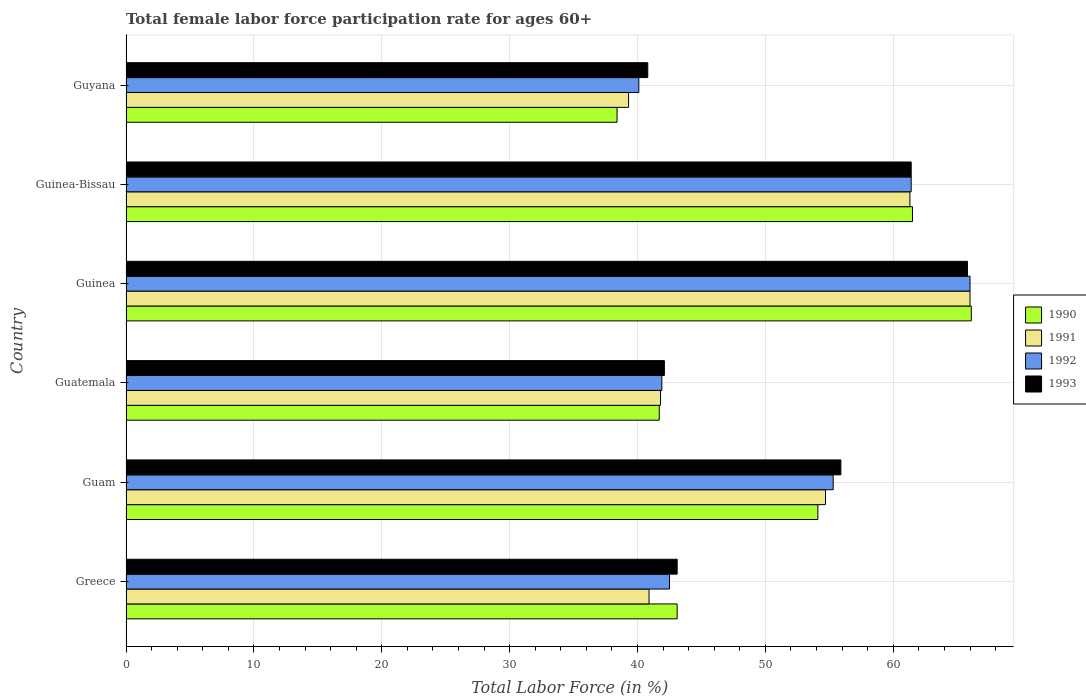How many groups of bars are there?
Your response must be concise. 6. Are the number of bars per tick equal to the number of legend labels?
Give a very brief answer. Yes. Are the number of bars on each tick of the Y-axis equal?
Your answer should be compact. Yes. How many bars are there on the 2nd tick from the top?
Your answer should be very brief. 4. What is the label of the 2nd group of bars from the top?
Your answer should be very brief. Guinea-Bissau. In how many cases, is the number of bars for a given country not equal to the number of legend labels?
Offer a very short reply. 0. What is the female labor force participation rate in 1993 in Guinea?
Keep it short and to the point. 65.8. Across all countries, what is the maximum female labor force participation rate in 1990?
Keep it short and to the point. 66.1. Across all countries, what is the minimum female labor force participation rate in 1991?
Your response must be concise. 39.3. In which country was the female labor force participation rate in 1992 maximum?
Offer a terse response. Guinea. In which country was the female labor force participation rate in 1993 minimum?
Your answer should be compact. Guyana. What is the total female labor force participation rate in 1993 in the graph?
Ensure brevity in your answer.  309.1. What is the difference between the female labor force participation rate in 1993 in Guinea-Bissau and that in Guyana?
Offer a terse response. 20.6. What is the difference between the female labor force participation rate in 1993 in Greece and the female labor force participation rate in 1992 in Guinea-Bissau?
Provide a short and direct response. -18.3. What is the average female labor force participation rate in 1990 per country?
Offer a very short reply. 50.82. What is the difference between the female labor force participation rate in 1992 and female labor force participation rate in 1993 in Guam?
Your answer should be very brief. -0.6. In how many countries, is the female labor force participation rate in 1993 greater than 2 %?
Offer a terse response. 6. What is the ratio of the female labor force participation rate in 1992 in Guam to that in Guatemala?
Ensure brevity in your answer.  1.32. Is the difference between the female labor force participation rate in 1992 in Greece and Guinea greater than the difference between the female labor force participation rate in 1993 in Greece and Guinea?
Your answer should be very brief. No. What is the difference between the highest and the second highest female labor force participation rate in 1991?
Offer a very short reply. 4.7. What is the difference between the highest and the lowest female labor force participation rate in 1991?
Offer a terse response. 26.7. In how many countries, is the female labor force participation rate in 1992 greater than the average female labor force participation rate in 1992 taken over all countries?
Provide a short and direct response. 3. Is the sum of the female labor force participation rate in 1993 in Guinea-Bissau and Guyana greater than the maximum female labor force participation rate in 1990 across all countries?
Your response must be concise. Yes. Is it the case that in every country, the sum of the female labor force participation rate in 1990 and female labor force participation rate in 1992 is greater than the sum of female labor force participation rate in 1993 and female labor force participation rate in 1991?
Offer a very short reply. No. What does the 4th bar from the bottom in Guam represents?
Your answer should be very brief. 1993. Is it the case that in every country, the sum of the female labor force participation rate in 1993 and female labor force participation rate in 1992 is greater than the female labor force participation rate in 1991?
Provide a short and direct response. Yes. How many bars are there?
Offer a terse response. 24. Does the graph contain any zero values?
Your answer should be very brief. No. Does the graph contain grids?
Provide a short and direct response. Yes. How many legend labels are there?
Ensure brevity in your answer.  4. How are the legend labels stacked?
Make the answer very short. Vertical. What is the title of the graph?
Offer a terse response. Total female labor force participation rate for ages 60+. Does "1984" appear as one of the legend labels in the graph?
Your answer should be compact. No. What is the label or title of the X-axis?
Offer a very short reply. Total Labor Force (in %). What is the Total Labor Force (in %) in 1990 in Greece?
Provide a succinct answer. 43.1. What is the Total Labor Force (in %) in 1991 in Greece?
Offer a terse response. 40.9. What is the Total Labor Force (in %) of 1992 in Greece?
Your answer should be compact. 42.5. What is the Total Labor Force (in %) of 1993 in Greece?
Ensure brevity in your answer.  43.1. What is the Total Labor Force (in %) of 1990 in Guam?
Keep it short and to the point. 54.1. What is the Total Labor Force (in %) of 1991 in Guam?
Offer a terse response. 54.7. What is the Total Labor Force (in %) in 1992 in Guam?
Give a very brief answer. 55.3. What is the Total Labor Force (in %) in 1993 in Guam?
Ensure brevity in your answer.  55.9. What is the Total Labor Force (in %) in 1990 in Guatemala?
Keep it short and to the point. 41.7. What is the Total Labor Force (in %) in 1991 in Guatemala?
Provide a succinct answer. 41.8. What is the Total Labor Force (in %) of 1992 in Guatemala?
Your response must be concise. 41.9. What is the Total Labor Force (in %) of 1993 in Guatemala?
Keep it short and to the point. 42.1. What is the Total Labor Force (in %) of 1990 in Guinea?
Ensure brevity in your answer.  66.1. What is the Total Labor Force (in %) in 1992 in Guinea?
Keep it short and to the point. 66. What is the Total Labor Force (in %) of 1993 in Guinea?
Ensure brevity in your answer.  65.8. What is the Total Labor Force (in %) in 1990 in Guinea-Bissau?
Offer a very short reply. 61.5. What is the Total Labor Force (in %) in 1991 in Guinea-Bissau?
Your answer should be compact. 61.3. What is the Total Labor Force (in %) of 1992 in Guinea-Bissau?
Make the answer very short. 61.4. What is the Total Labor Force (in %) of 1993 in Guinea-Bissau?
Offer a terse response. 61.4. What is the Total Labor Force (in %) in 1990 in Guyana?
Provide a short and direct response. 38.4. What is the Total Labor Force (in %) in 1991 in Guyana?
Your answer should be compact. 39.3. What is the Total Labor Force (in %) in 1992 in Guyana?
Provide a short and direct response. 40.1. What is the Total Labor Force (in %) in 1993 in Guyana?
Your answer should be very brief. 40.8. Across all countries, what is the maximum Total Labor Force (in %) of 1990?
Keep it short and to the point. 66.1. Across all countries, what is the maximum Total Labor Force (in %) of 1992?
Make the answer very short. 66. Across all countries, what is the maximum Total Labor Force (in %) of 1993?
Keep it short and to the point. 65.8. Across all countries, what is the minimum Total Labor Force (in %) of 1990?
Keep it short and to the point. 38.4. Across all countries, what is the minimum Total Labor Force (in %) in 1991?
Your answer should be compact. 39.3. Across all countries, what is the minimum Total Labor Force (in %) of 1992?
Your answer should be very brief. 40.1. Across all countries, what is the minimum Total Labor Force (in %) of 1993?
Provide a succinct answer. 40.8. What is the total Total Labor Force (in %) of 1990 in the graph?
Your response must be concise. 304.9. What is the total Total Labor Force (in %) in 1991 in the graph?
Keep it short and to the point. 304. What is the total Total Labor Force (in %) of 1992 in the graph?
Your answer should be compact. 307.2. What is the total Total Labor Force (in %) in 1993 in the graph?
Ensure brevity in your answer.  309.1. What is the difference between the Total Labor Force (in %) of 1990 in Greece and that in Guam?
Offer a terse response. -11. What is the difference between the Total Labor Force (in %) of 1991 in Greece and that in Guam?
Give a very brief answer. -13.8. What is the difference between the Total Labor Force (in %) of 1992 in Greece and that in Guam?
Keep it short and to the point. -12.8. What is the difference between the Total Labor Force (in %) in 1990 in Greece and that in Guatemala?
Keep it short and to the point. 1.4. What is the difference between the Total Labor Force (in %) of 1992 in Greece and that in Guatemala?
Provide a short and direct response. 0.6. What is the difference between the Total Labor Force (in %) of 1993 in Greece and that in Guatemala?
Keep it short and to the point. 1. What is the difference between the Total Labor Force (in %) in 1990 in Greece and that in Guinea?
Give a very brief answer. -23. What is the difference between the Total Labor Force (in %) of 1991 in Greece and that in Guinea?
Your answer should be compact. -25.1. What is the difference between the Total Labor Force (in %) of 1992 in Greece and that in Guinea?
Keep it short and to the point. -23.5. What is the difference between the Total Labor Force (in %) in 1993 in Greece and that in Guinea?
Your answer should be very brief. -22.7. What is the difference between the Total Labor Force (in %) of 1990 in Greece and that in Guinea-Bissau?
Provide a succinct answer. -18.4. What is the difference between the Total Labor Force (in %) of 1991 in Greece and that in Guinea-Bissau?
Make the answer very short. -20.4. What is the difference between the Total Labor Force (in %) in 1992 in Greece and that in Guinea-Bissau?
Keep it short and to the point. -18.9. What is the difference between the Total Labor Force (in %) in 1993 in Greece and that in Guinea-Bissau?
Provide a short and direct response. -18.3. What is the difference between the Total Labor Force (in %) in 1993 in Greece and that in Guyana?
Your answer should be compact. 2.3. What is the difference between the Total Labor Force (in %) in 1993 in Guam and that in Guatemala?
Make the answer very short. 13.8. What is the difference between the Total Labor Force (in %) of 1991 in Guam and that in Guinea?
Your answer should be compact. -11.3. What is the difference between the Total Labor Force (in %) in 1992 in Guam and that in Guinea?
Provide a succinct answer. -10.7. What is the difference between the Total Labor Force (in %) in 1991 in Guam and that in Guinea-Bissau?
Ensure brevity in your answer.  -6.6. What is the difference between the Total Labor Force (in %) in 1993 in Guam and that in Guyana?
Your answer should be compact. 15.1. What is the difference between the Total Labor Force (in %) of 1990 in Guatemala and that in Guinea?
Provide a short and direct response. -24.4. What is the difference between the Total Labor Force (in %) in 1991 in Guatemala and that in Guinea?
Provide a succinct answer. -24.2. What is the difference between the Total Labor Force (in %) in 1992 in Guatemala and that in Guinea?
Give a very brief answer. -24.1. What is the difference between the Total Labor Force (in %) of 1993 in Guatemala and that in Guinea?
Make the answer very short. -23.7. What is the difference between the Total Labor Force (in %) in 1990 in Guatemala and that in Guinea-Bissau?
Ensure brevity in your answer.  -19.8. What is the difference between the Total Labor Force (in %) in 1991 in Guatemala and that in Guinea-Bissau?
Provide a succinct answer. -19.5. What is the difference between the Total Labor Force (in %) of 1992 in Guatemala and that in Guinea-Bissau?
Provide a succinct answer. -19.5. What is the difference between the Total Labor Force (in %) in 1993 in Guatemala and that in Guinea-Bissau?
Your answer should be compact. -19.3. What is the difference between the Total Labor Force (in %) of 1990 in Guatemala and that in Guyana?
Your answer should be very brief. 3.3. What is the difference between the Total Labor Force (in %) in 1993 in Guatemala and that in Guyana?
Your response must be concise. 1.3. What is the difference between the Total Labor Force (in %) in 1991 in Guinea and that in Guinea-Bissau?
Give a very brief answer. 4.7. What is the difference between the Total Labor Force (in %) in 1993 in Guinea and that in Guinea-Bissau?
Provide a short and direct response. 4.4. What is the difference between the Total Labor Force (in %) of 1990 in Guinea and that in Guyana?
Offer a terse response. 27.7. What is the difference between the Total Labor Force (in %) of 1991 in Guinea and that in Guyana?
Offer a very short reply. 26.7. What is the difference between the Total Labor Force (in %) of 1992 in Guinea and that in Guyana?
Provide a short and direct response. 25.9. What is the difference between the Total Labor Force (in %) of 1993 in Guinea and that in Guyana?
Offer a terse response. 25. What is the difference between the Total Labor Force (in %) of 1990 in Guinea-Bissau and that in Guyana?
Your response must be concise. 23.1. What is the difference between the Total Labor Force (in %) in 1992 in Guinea-Bissau and that in Guyana?
Provide a short and direct response. 21.3. What is the difference between the Total Labor Force (in %) of 1993 in Guinea-Bissau and that in Guyana?
Keep it short and to the point. 20.6. What is the difference between the Total Labor Force (in %) of 1990 in Greece and the Total Labor Force (in %) of 1991 in Guam?
Your answer should be compact. -11.6. What is the difference between the Total Labor Force (in %) in 1990 in Greece and the Total Labor Force (in %) in 1992 in Guam?
Your response must be concise. -12.2. What is the difference between the Total Labor Force (in %) of 1991 in Greece and the Total Labor Force (in %) of 1992 in Guam?
Keep it short and to the point. -14.4. What is the difference between the Total Labor Force (in %) of 1990 in Greece and the Total Labor Force (in %) of 1992 in Guatemala?
Your answer should be compact. 1.2. What is the difference between the Total Labor Force (in %) of 1992 in Greece and the Total Labor Force (in %) of 1993 in Guatemala?
Make the answer very short. 0.4. What is the difference between the Total Labor Force (in %) in 1990 in Greece and the Total Labor Force (in %) in 1991 in Guinea?
Keep it short and to the point. -22.9. What is the difference between the Total Labor Force (in %) of 1990 in Greece and the Total Labor Force (in %) of 1992 in Guinea?
Ensure brevity in your answer.  -22.9. What is the difference between the Total Labor Force (in %) in 1990 in Greece and the Total Labor Force (in %) in 1993 in Guinea?
Give a very brief answer. -22.7. What is the difference between the Total Labor Force (in %) in 1991 in Greece and the Total Labor Force (in %) in 1992 in Guinea?
Offer a very short reply. -25.1. What is the difference between the Total Labor Force (in %) of 1991 in Greece and the Total Labor Force (in %) of 1993 in Guinea?
Offer a terse response. -24.9. What is the difference between the Total Labor Force (in %) in 1992 in Greece and the Total Labor Force (in %) in 1993 in Guinea?
Your answer should be compact. -23.3. What is the difference between the Total Labor Force (in %) in 1990 in Greece and the Total Labor Force (in %) in 1991 in Guinea-Bissau?
Give a very brief answer. -18.2. What is the difference between the Total Labor Force (in %) of 1990 in Greece and the Total Labor Force (in %) of 1992 in Guinea-Bissau?
Offer a very short reply. -18.3. What is the difference between the Total Labor Force (in %) in 1990 in Greece and the Total Labor Force (in %) in 1993 in Guinea-Bissau?
Your response must be concise. -18.3. What is the difference between the Total Labor Force (in %) in 1991 in Greece and the Total Labor Force (in %) in 1992 in Guinea-Bissau?
Give a very brief answer. -20.5. What is the difference between the Total Labor Force (in %) in 1991 in Greece and the Total Labor Force (in %) in 1993 in Guinea-Bissau?
Offer a very short reply. -20.5. What is the difference between the Total Labor Force (in %) of 1992 in Greece and the Total Labor Force (in %) of 1993 in Guinea-Bissau?
Give a very brief answer. -18.9. What is the difference between the Total Labor Force (in %) in 1990 in Greece and the Total Labor Force (in %) in 1991 in Guyana?
Ensure brevity in your answer.  3.8. What is the difference between the Total Labor Force (in %) in 1991 in Greece and the Total Labor Force (in %) in 1993 in Guyana?
Give a very brief answer. 0.1. What is the difference between the Total Labor Force (in %) in 1991 in Guam and the Total Labor Force (in %) in 1993 in Guatemala?
Provide a short and direct response. 12.6. What is the difference between the Total Labor Force (in %) of 1990 in Guam and the Total Labor Force (in %) of 1991 in Guinea?
Your response must be concise. -11.9. What is the difference between the Total Labor Force (in %) in 1990 in Guam and the Total Labor Force (in %) in 1993 in Guinea?
Give a very brief answer. -11.7. What is the difference between the Total Labor Force (in %) in 1991 in Guam and the Total Labor Force (in %) in 1992 in Guinea?
Your answer should be compact. -11.3. What is the difference between the Total Labor Force (in %) of 1992 in Guam and the Total Labor Force (in %) of 1993 in Guinea?
Ensure brevity in your answer.  -10.5. What is the difference between the Total Labor Force (in %) of 1990 in Guam and the Total Labor Force (in %) of 1993 in Guinea-Bissau?
Make the answer very short. -7.3. What is the difference between the Total Labor Force (in %) in 1991 in Guam and the Total Labor Force (in %) in 1992 in Guinea-Bissau?
Your answer should be very brief. -6.7. What is the difference between the Total Labor Force (in %) of 1990 in Guam and the Total Labor Force (in %) of 1992 in Guyana?
Keep it short and to the point. 14. What is the difference between the Total Labor Force (in %) in 1991 in Guam and the Total Labor Force (in %) in 1993 in Guyana?
Offer a terse response. 13.9. What is the difference between the Total Labor Force (in %) in 1992 in Guam and the Total Labor Force (in %) in 1993 in Guyana?
Your response must be concise. 14.5. What is the difference between the Total Labor Force (in %) of 1990 in Guatemala and the Total Labor Force (in %) of 1991 in Guinea?
Your answer should be very brief. -24.3. What is the difference between the Total Labor Force (in %) of 1990 in Guatemala and the Total Labor Force (in %) of 1992 in Guinea?
Offer a terse response. -24.3. What is the difference between the Total Labor Force (in %) in 1990 in Guatemala and the Total Labor Force (in %) in 1993 in Guinea?
Provide a short and direct response. -24.1. What is the difference between the Total Labor Force (in %) in 1991 in Guatemala and the Total Labor Force (in %) in 1992 in Guinea?
Give a very brief answer. -24.2. What is the difference between the Total Labor Force (in %) of 1992 in Guatemala and the Total Labor Force (in %) of 1993 in Guinea?
Give a very brief answer. -23.9. What is the difference between the Total Labor Force (in %) in 1990 in Guatemala and the Total Labor Force (in %) in 1991 in Guinea-Bissau?
Provide a succinct answer. -19.6. What is the difference between the Total Labor Force (in %) of 1990 in Guatemala and the Total Labor Force (in %) of 1992 in Guinea-Bissau?
Your answer should be compact. -19.7. What is the difference between the Total Labor Force (in %) in 1990 in Guatemala and the Total Labor Force (in %) in 1993 in Guinea-Bissau?
Give a very brief answer. -19.7. What is the difference between the Total Labor Force (in %) in 1991 in Guatemala and the Total Labor Force (in %) in 1992 in Guinea-Bissau?
Provide a succinct answer. -19.6. What is the difference between the Total Labor Force (in %) of 1991 in Guatemala and the Total Labor Force (in %) of 1993 in Guinea-Bissau?
Make the answer very short. -19.6. What is the difference between the Total Labor Force (in %) in 1992 in Guatemala and the Total Labor Force (in %) in 1993 in Guinea-Bissau?
Give a very brief answer. -19.5. What is the difference between the Total Labor Force (in %) of 1990 in Guatemala and the Total Labor Force (in %) of 1991 in Guyana?
Give a very brief answer. 2.4. What is the difference between the Total Labor Force (in %) of 1991 in Guatemala and the Total Labor Force (in %) of 1992 in Guyana?
Offer a terse response. 1.7. What is the difference between the Total Labor Force (in %) in 1991 in Guatemala and the Total Labor Force (in %) in 1993 in Guyana?
Offer a very short reply. 1. What is the difference between the Total Labor Force (in %) of 1990 in Guinea and the Total Labor Force (in %) of 1991 in Guinea-Bissau?
Offer a terse response. 4.8. What is the difference between the Total Labor Force (in %) of 1990 in Guinea and the Total Labor Force (in %) of 1992 in Guinea-Bissau?
Make the answer very short. 4.7. What is the difference between the Total Labor Force (in %) of 1990 in Guinea and the Total Labor Force (in %) of 1991 in Guyana?
Provide a short and direct response. 26.8. What is the difference between the Total Labor Force (in %) in 1990 in Guinea and the Total Labor Force (in %) in 1993 in Guyana?
Offer a very short reply. 25.3. What is the difference between the Total Labor Force (in %) in 1991 in Guinea and the Total Labor Force (in %) in 1992 in Guyana?
Offer a very short reply. 25.9. What is the difference between the Total Labor Force (in %) in 1991 in Guinea and the Total Labor Force (in %) in 1993 in Guyana?
Offer a terse response. 25.2. What is the difference between the Total Labor Force (in %) in 1992 in Guinea and the Total Labor Force (in %) in 1993 in Guyana?
Provide a short and direct response. 25.2. What is the difference between the Total Labor Force (in %) of 1990 in Guinea-Bissau and the Total Labor Force (in %) of 1992 in Guyana?
Offer a terse response. 21.4. What is the difference between the Total Labor Force (in %) of 1990 in Guinea-Bissau and the Total Labor Force (in %) of 1993 in Guyana?
Your response must be concise. 20.7. What is the difference between the Total Labor Force (in %) of 1991 in Guinea-Bissau and the Total Labor Force (in %) of 1992 in Guyana?
Offer a terse response. 21.2. What is the difference between the Total Labor Force (in %) of 1992 in Guinea-Bissau and the Total Labor Force (in %) of 1993 in Guyana?
Offer a terse response. 20.6. What is the average Total Labor Force (in %) of 1990 per country?
Your response must be concise. 50.82. What is the average Total Labor Force (in %) in 1991 per country?
Ensure brevity in your answer.  50.67. What is the average Total Labor Force (in %) of 1992 per country?
Provide a short and direct response. 51.2. What is the average Total Labor Force (in %) in 1993 per country?
Your answer should be very brief. 51.52. What is the difference between the Total Labor Force (in %) of 1990 and Total Labor Force (in %) of 1991 in Greece?
Provide a short and direct response. 2.2. What is the difference between the Total Labor Force (in %) of 1990 and Total Labor Force (in %) of 1992 in Greece?
Make the answer very short. 0.6. What is the difference between the Total Labor Force (in %) of 1991 and Total Labor Force (in %) of 1992 in Greece?
Offer a very short reply. -1.6. What is the difference between the Total Labor Force (in %) of 1991 and Total Labor Force (in %) of 1993 in Greece?
Make the answer very short. -2.2. What is the difference between the Total Labor Force (in %) in 1990 and Total Labor Force (in %) in 1993 in Guam?
Your response must be concise. -1.8. What is the difference between the Total Labor Force (in %) of 1991 and Total Labor Force (in %) of 1993 in Guam?
Provide a succinct answer. -1.2. What is the difference between the Total Labor Force (in %) in 1992 and Total Labor Force (in %) in 1993 in Guam?
Your answer should be compact. -0.6. What is the difference between the Total Labor Force (in %) in 1990 and Total Labor Force (in %) in 1993 in Guatemala?
Offer a terse response. -0.4. What is the difference between the Total Labor Force (in %) of 1991 and Total Labor Force (in %) of 1992 in Guatemala?
Give a very brief answer. -0.1. What is the difference between the Total Labor Force (in %) of 1992 and Total Labor Force (in %) of 1993 in Guatemala?
Your answer should be very brief. -0.2. What is the difference between the Total Labor Force (in %) of 1990 and Total Labor Force (in %) of 1991 in Guinea?
Make the answer very short. 0.1. What is the difference between the Total Labor Force (in %) in 1990 and Total Labor Force (in %) in 1992 in Guinea?
Give a very brief answer. 0.1. What is the difference between the Total Labor Force (in %) of 1992 and Total Labor Force (in %) of 1993 in Guinea?
Your answer should be very brief. 0.2. What is the difference between the Total Labor Force (in %) in 1990 and Total Labor Force (in %) in 1991 in Guinea-Bissau?
Provide a short and direct response. 0.2. What is the difference between the Total Labor Force (in %) of 1990 and Total Labor Force (in %) of 1993 in Guinea-Bissau?
Provide a succinct answer. 0.1. What is the difference between the Total Labor Force (in %) in 1991 and Total Labor Force (in %) in 1992 in Guinea-Bissau?
Your response must be concise. -0.1. What is the difference between the Total Labor Force (in %) in 1991 and Total Labor Force (in %) in 1993 in Guinea-Bissau?
Provide a short and direct response. -0.1. What is the difference between the Total Labor Force (in %) in 1990 and Total Labor Force (in %) in 1991 in Guyana?
Keep it short and to the point. -0.9. What is the difference between the Total Labor Force (in %) in 1990 and Total Labor Force (in %) in 1992 in Guyana?
Offer a very short reply. -1.7. What is the difference between the Total Labor Force (in %) of 1990 and Total Labor Force (in %) of 1993 in Guyana?
Give a very brief answer. -2.4. What is the difference between the Total Labor Force (in %) in 1991 and Total Labor Force (in %) in 1993 in Guyana?
Ensure brevity in your answer.  -1.5. What is the ratio of the Total Labor Force (in %) of 1990 in Greece to that in Guam?
Your answer should be compact. 0.8. What is the ratio of the Total Labor Force (in %) in 1991 in Greece to that in Guam?
Offer a very short reply. 0.75. What is the ratio of the Total Labor Force (in %) in 1992 in Greece to that in Guam?
Offer a very short reply. 0.77. What is the ratio of the Total Labor Force (in %) in 1993 in Greece to that in Guam?
Your answer should be compact. 0.77. What is the ratio of the Total Labor Force (in %) in 1990 in Greece to that in Guatemala?
Offer a very short reply. 1.03. What is the ratio of the Total Labor Force (in %) in 1991 in Greece to that in Guatemala?
Provide a succinct answer. 0.98. What is the ratio of the Total Labor Force (in %) in 1992 in Greece to that in Guatemala?
Provide a short and direct response. 1.01. What is the ratio of the Total Labor Force (in %) of 1993 in Greece to that in Guatemala?
Offer a very short reply. 1.02. What is the ratio of the Total Labor Force (in %) in 1990 in Greece to that in Guinea?
Offer a terse response. 0.65. What is the ratio of the Total Labor Force (in %) in 1991 in Greece to that in Guinea?
Your response must be concise. 0.62. What is the ratio of the Total Labor Force (in %) in 1992 in Greece to that in Guinea?
Your response must be concise. 0.64. What is the ratio of the Total Labor Force (in %) of 1993 in Greece to that in Guinea?
Provide a succinct answer. 0.66. What is the ratio of the Total Labor Force (in %) in 1990 in Greece to that in Guinea-Bissau?
Your answer should be very brief. 0.7. What is the ratio of the Total Labor Force (in %) in 1991 in Greece to that in Guinea-Bissau?
Provide a short and direct response. 0.67. What is the ratio of the Total Labor Force (in %) in 1992 in Greece to that in Guinea-Bissau?
Offer a terse response. 0.69. What is the ratio of the Total Labor Force (in %) in 1993 in Greece to that in Guinea-Bissau?
Give a very brief answer. 0.7. What is the ratio of the Total Labor Force (in %) in 1990 in Greece to that in Guyana?
Offer a terse response. 1.12. What is the ratio of the Total Labor Force (in %) of 1991 in Greece to that in Guyana?
Keep it short and to the point. 1.04. What is the ratio of the Total Labor Force (in %) of 1992 in Greece to that in Guyana?
Make the answer very short. 1.06. What is the ratio of the Total Labor Force (in %) in 1993 in Greece to that in Guyana?
Your response must be concise. 1.06. What is the ratio of the Total Labor Force (in %) of 1990 in Guam to that in Guatemala?
Make the answer very short. 1.3. What is the ratio of the Total Labor Force (in %) of 1991 in Guam to that in Guatemala?
Keep it short and to the point. 1.31. What is the ratio of the Total Labor Force (in %) of 1992 in Guam to that in Guatemala?
Keep it short and to the point. 1.32. What is the ratio of the Total Labor Force (in %) of 1993 in Guam to that in Guatemala?
Offer a terse response. 1.33. What is the ratio of the Total Labor Force (in %) of 1990 in Guam to that in Guinea?
Your response must be concise. 0.82. What is the ratio of the Total Labor Force (in %) of 1991 in Guam to that in Guinea?
Keep it short and to the point. 0.83. What is the ratio of the Total Labor Force (in %) in 1992 in Guam to that in Guinea?
Give a very brief answer. 0.84. What is the ratio of the Total Labor Force (in %) of 1993 in Guam to that in Guinea?
Make the answer very short. 0.85. What is the ratio of the Total Labor Force (in %) in 1990 in Guam to that in Guinea-Bissau?
Your response must be concise. 0.88. What is the ratio of the Total Labor Force (in %) in 1991 in Guam to that in Guinea-Bissau?
Your answer should be very brief. 0.89. What is the ratio of the Total Labor Force (in %) in 1992 in Guam to that in Guinea-Bissau?
Your answer should be compact. 0.9. What is the ratio of the Total Labor Force (in %) of 1993 in Guam to that in Guinea-Bissau?
Ensure brevity in your answer.  0.91. What is the ratio of the Total Labor Force (in %) of 1990 in Guam to that in Guyana?
Give a very brief answer. 1.41. What is the ratio of the Total Labor Force (in %) of 1991 in Guam to that in Guyana?
Offer a terse response. 1.39. What is the ratio of the Total Labor Force (in %) of 1992 in Guam to that in Guyana?
Give a very brief answer. 1.38. What is the ratio of the Total Labor Force (in %) of 1993 in Guam to that in Guyana?
Your answer should be very brief. 1.37. What is the ratio of the Total Labor Force (in %) of 1990 in Guatemala to that in Guinea?
Offer a very short reply. 0.63. What is the ratio of the Total Labor Force (in %) of 1991 in Guatemala to that in Guinea?
Give a very brief answer. 0.63. What is the ratio of the Total Labor Force (in %) in 1992 in Guatemala to that in Guinea?
Your answer should be compact. 0.63. What is the ratio of the Total Labor Force (in %) in 1993 in Guatemala to that in Guinea?
Ensure brevity in your answer.  0.64. What is the ratio of the Total Labor Force (in %) of 1990 in Guatemala to that in Guinea-Bissau?
Provide a succinct answer. 0.68. What is the ratio of the Total Labor Force (in %) of 1991 in Guatemala to that in Guinea-Bissau?
Offer a terse response. 0.68. What is the ratio of the Total Labor Force (in %) in 1992 in Guatemala to that in Guinea-Bissau?
Your answer should be very brief. 0.68. What is the ratio of the Total Labor Force (in %) in 1993 in Guatemala to that in Guinea-Bissau?
Provide a short and direct response. 0.69. What is the ratio of the Total Labor Force (in %) of 1990 in Guatemala to that in Guyana?
Make the answer very short. 1.09. What is the ratio of the Total Labor Force (in %) of 1991 in Guatemala to that in Guyana?
Provide a short and direct response. 1.06. What is the ratio of the Total Labor Force (in %) in 1992 in Guatemala to that in Guyana?
Give a very brief answer. 1.04. What is the ratio of the Total Labor Force (in %) of 1993 in Guatemala to that in Guyana?
Offer a very short reply. 1.03. What is the ratio of the Total Labor Force (in %) in 1990 in Guinea to that in Guinea-Bissau?
Keep it short and to the point. 1.07. What is the ratio of the Total Labor Force (in %) of 1991 in Guinea to that in Guinea-Bissau?
Keep it short and to the point. 1.08. What is the ratio of the Total Labor Force (in %) of 1992 in Guinea to that in Guinea-Bissau?
Offer a very short reply. 1.07. What is the ratio of the Total Labor Force (in %) of 1993 in Guinea to that in Guinea-Bissau?
Keep it short and to the point. 1.07. What is the ratio of the Total Labor Force (in %) of 1990 in Guinea to that in Guyana?
Make the answer very short. 1.72. What is the ratio of the Total Labor Force (in %) in 1991 in Guinea to that in Guyana?
Keep it short and to the point. 1.68. What is the ratio of the Total Labor Force (in %) in 1992 in Guinea to that in Guyana?
Provide a short and direct response. 1.65. What is the ratio of the Total Labor Force (in %) of 1993 in Guinea to that in Guyana?
Ensure brevity in your answer.  1.61. What is the ratio of the Total Labor Force (in %) in 1990 in Guinea-Bissau to that in Guyana?
Give a very brief answer. 1.6. What is the ratio of the Total Labor Force (in %) in 1991 in Guinea-Bissau to that in Guyana?
Offer a very short reply. 1.56. What is the ratio of the Total Labor Force (in %) in 1992 in Guinea-Bissau to that in Guyana?
Give a very brief answer. 1.53. What is the ratio of the Total Labor Force (in %) in 1993 in Guinea-Bissau to that in Guyana?
Ensure brevity in your answer.  1.5. What is the difference between the highest and the second highest Total Labor Force (in %) of 1990?
Your response must be concise. 4.6. What is the difference between the highest and the second highest Total Labor Force (in %) in 1993?
Your response must be concise. 4.4. What is the difference between the highest and the lowest Total Labor Force (in %) of 1990?
Provide a short and direct response. 27.7. What is the difference between the highest and the lowest Total Labor Force (in %) of 1991?
Offer a terse response. 26.7. What is the difference between the highest and the lowest Total Labor Force (in %) of 1992?
Provide a succinct answer. 25.9. What is the difference between the highest and the lowest Total Labor Force (in %) of 1993?
Your answer should be compact. 25. 